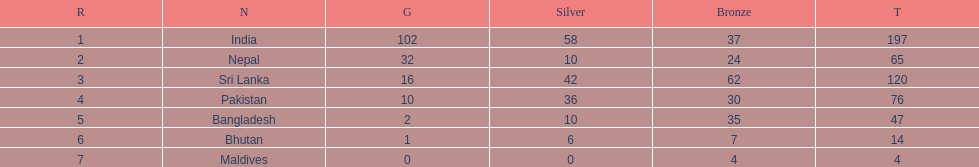Who is the top bronze medal winner in history? Sri Lanka. 